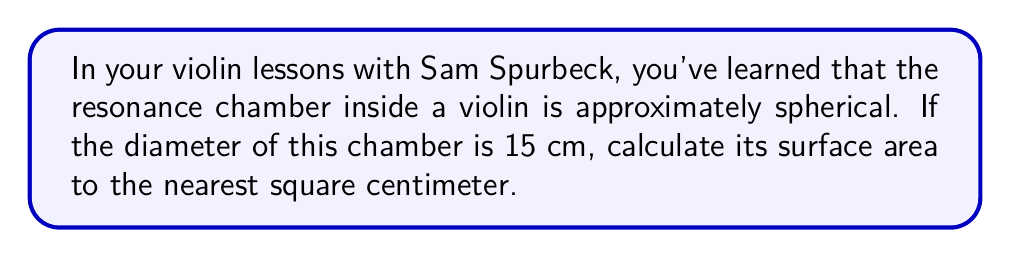Give your solution to this math problem. Let's approach this step-by-step:

1) The formula for the surface area of a sphere is:
   $$A = 4\pi r^2$$
   where $A$ is the surface area and $r$ is the radius of the sphere.

2) We're given the diameter, which is 15 cm. To find the radius, we divide the diameter by 2:
   $$r = \frac{15}{2} = 7.5 \text{ cm}$$

3) Now we can substitute this into our formula:
   $$A = 4\pi (7.5)^2$$

4) Let's calculate:
   $$A = 4\pi (56.25)$$
   $$A = 225\pi$$

5) Using $\pi \approx 3.14159$, we get:
   $$A \approx 225 * 3.14159 = 706.85775 \text{ cm}^2$$

6) Rounding to the nearest square centimeter:
   $$A \approx 707 \text{ cm}^2$$

[asy]
import geometry;

size(100);
draw(circle((0,0),1), blue);
dot((0,0));
draw((0,0)--(1,0), dashed);
label("$r$", (0.5,0), S);
label("Resonance Chamber", (0,-1.3));
[/asy]
Answer: 707 cm² 